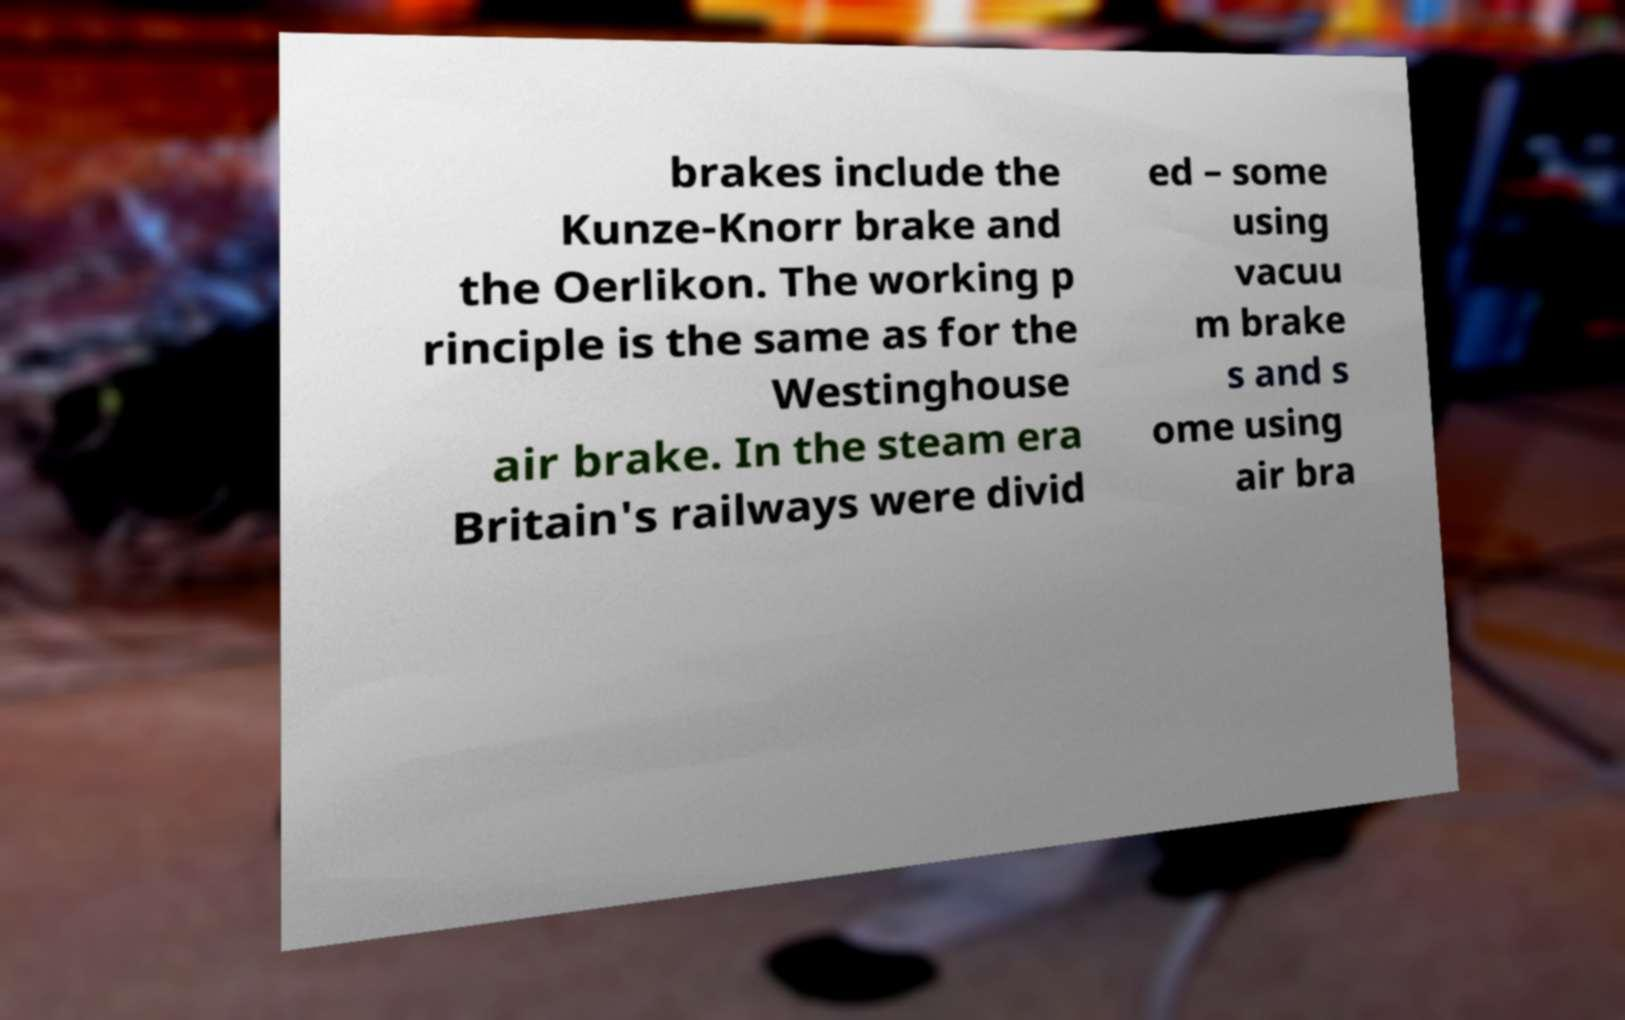What messages or text are displayed in this image? I need them in a readable, typed format. brakes include the Kunze-Knorr brake and the Oerlikon. The working p rinciple is the same as for the Westinghouse air brake. In the steam era Britain's railways were divid ed – some using vacuu m brake s and s ome using air bra 